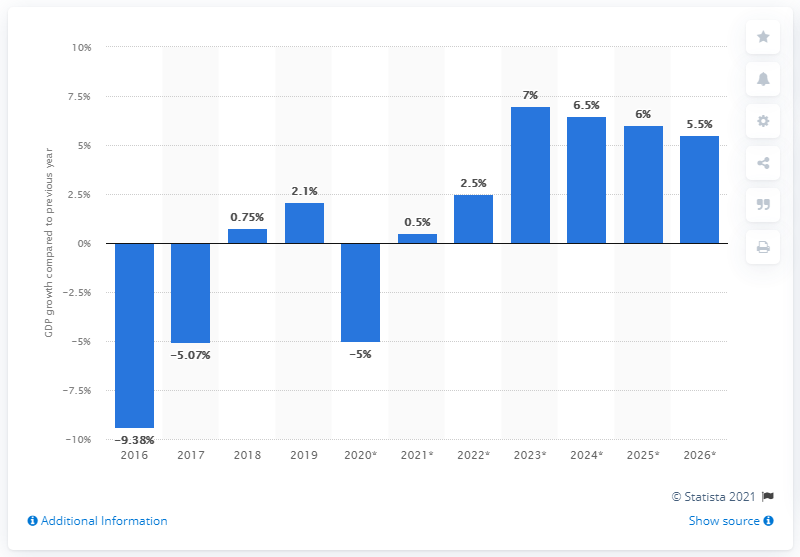Specify some key components in this picture. Yemen's Gross Domestic Product (GDP) increased by 2.1% in 2019. 